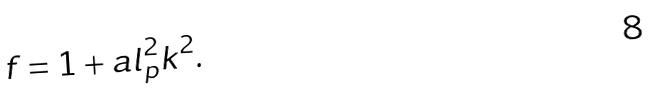Convert formula to latex. <formula><loc_0><loc_0><loc_500><loc_500>f = 1 + a l _ { p } ^ { 2 } k ^ { 2 } .</formula> 